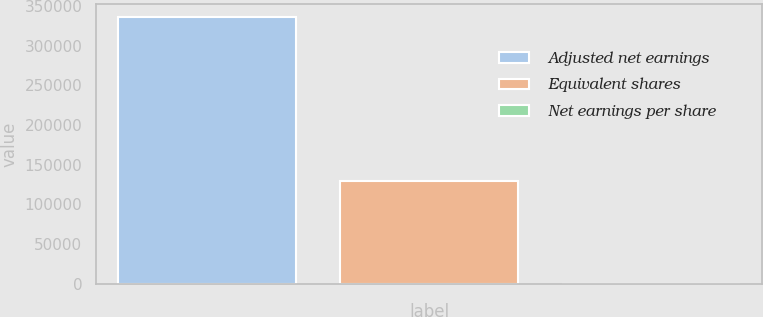Convert chart to OTSL. <chart><loc_0><loc_0><loc_500><loc_500><bar_chart><fcel>Adjusted net earnings<fcel>Equivalent shares<fcel>Net earnings per share<nl><fcel>335999<fcel>130067<fcel>2.58<nl></chart> 